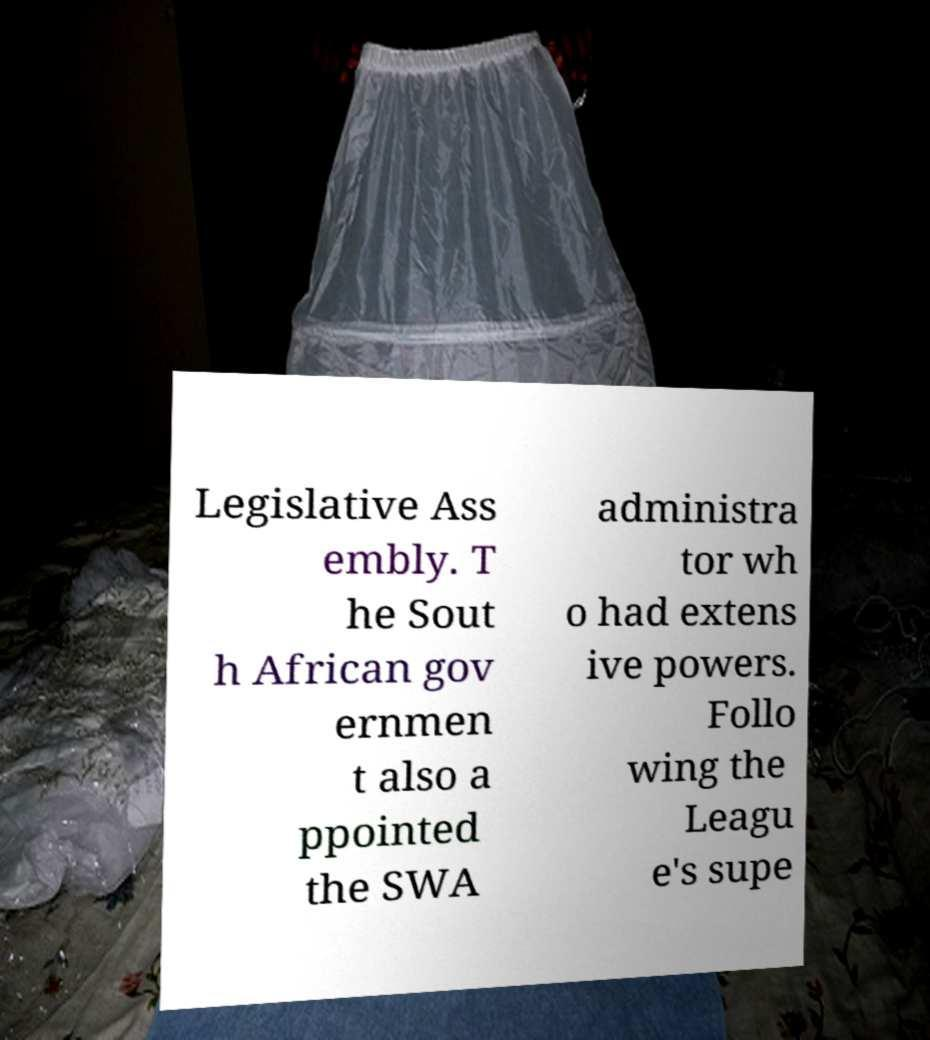What messages or text are displayed in this image? I need them in a readable, typed format. Legislative Ass embly. T he Sout h African gov ernmen t also a ppointed the SWA administra tor wh o had extens ive powers. Follo wing the Leagu e's supe 